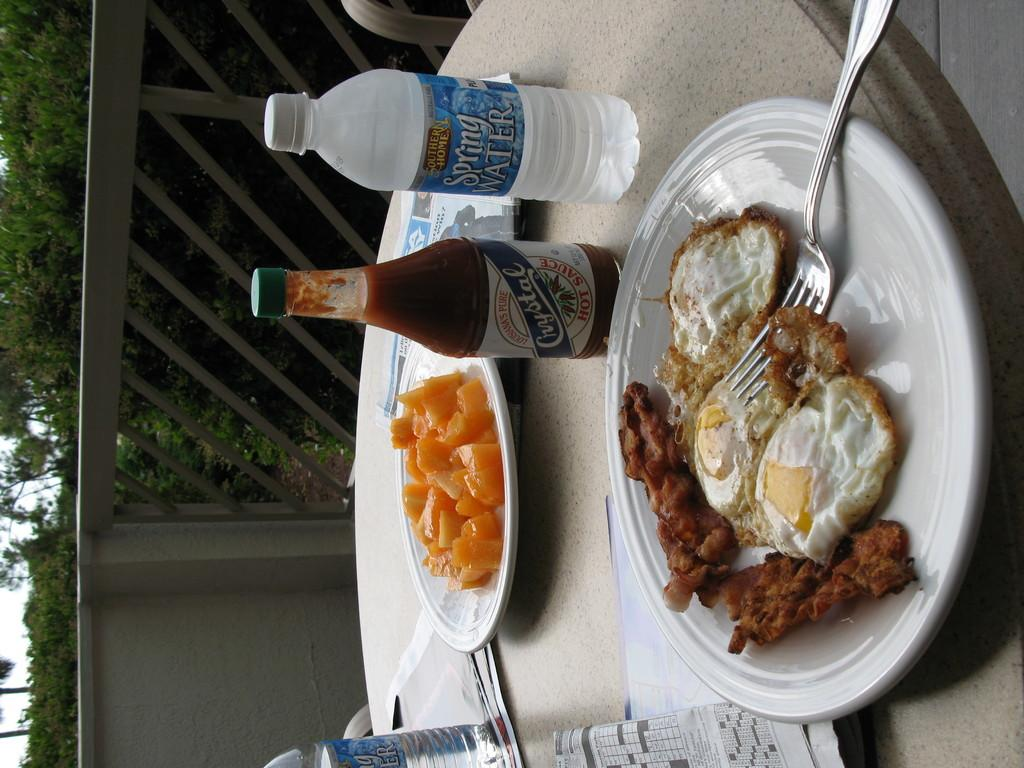What types of food items can be seen in the image? There are food items in the image, but the specific types are not mentioned. What is the beverage container present in the image? There is a water bottle in the image. What accompanies the food items in the image? There is sauce in the image. Where are these items located in the image? These items are kept on a table. What can be seen in the background of the image? There are many trees visible behind the table. How many oranges are on the table in the image? There is no mention of oranges in the image, so we cannot determine their presence or quantity. Is there a plane visible in the image? There is no mention of a plane in the image, so we cannot determine its presence. 